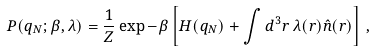<formula> <loc_0><loc_0><loc_500><loc_500>P ( q _ { N } ; \beta , \lambda ) = \frac { 1 } { Z } \exp - \beta \left [ H ( q _ { N } ) + \int d ^ { 3 } r \, \lambda ( r ) \hat { n } ( r ) \right ] \, ,</formula> 